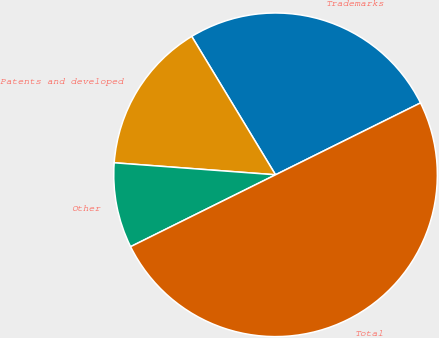Convert chart to OTSL. <chart><loc_0><loc_0><loc_500><loc_500><pie_chart><fcel>Trademarks<fcel>Patents and developed<fcel>Other<fcel>Total<nl><fcel>26.34%<fcel>15.15%<fcel>8.51%<fcel>50.0%<nl></chart> 